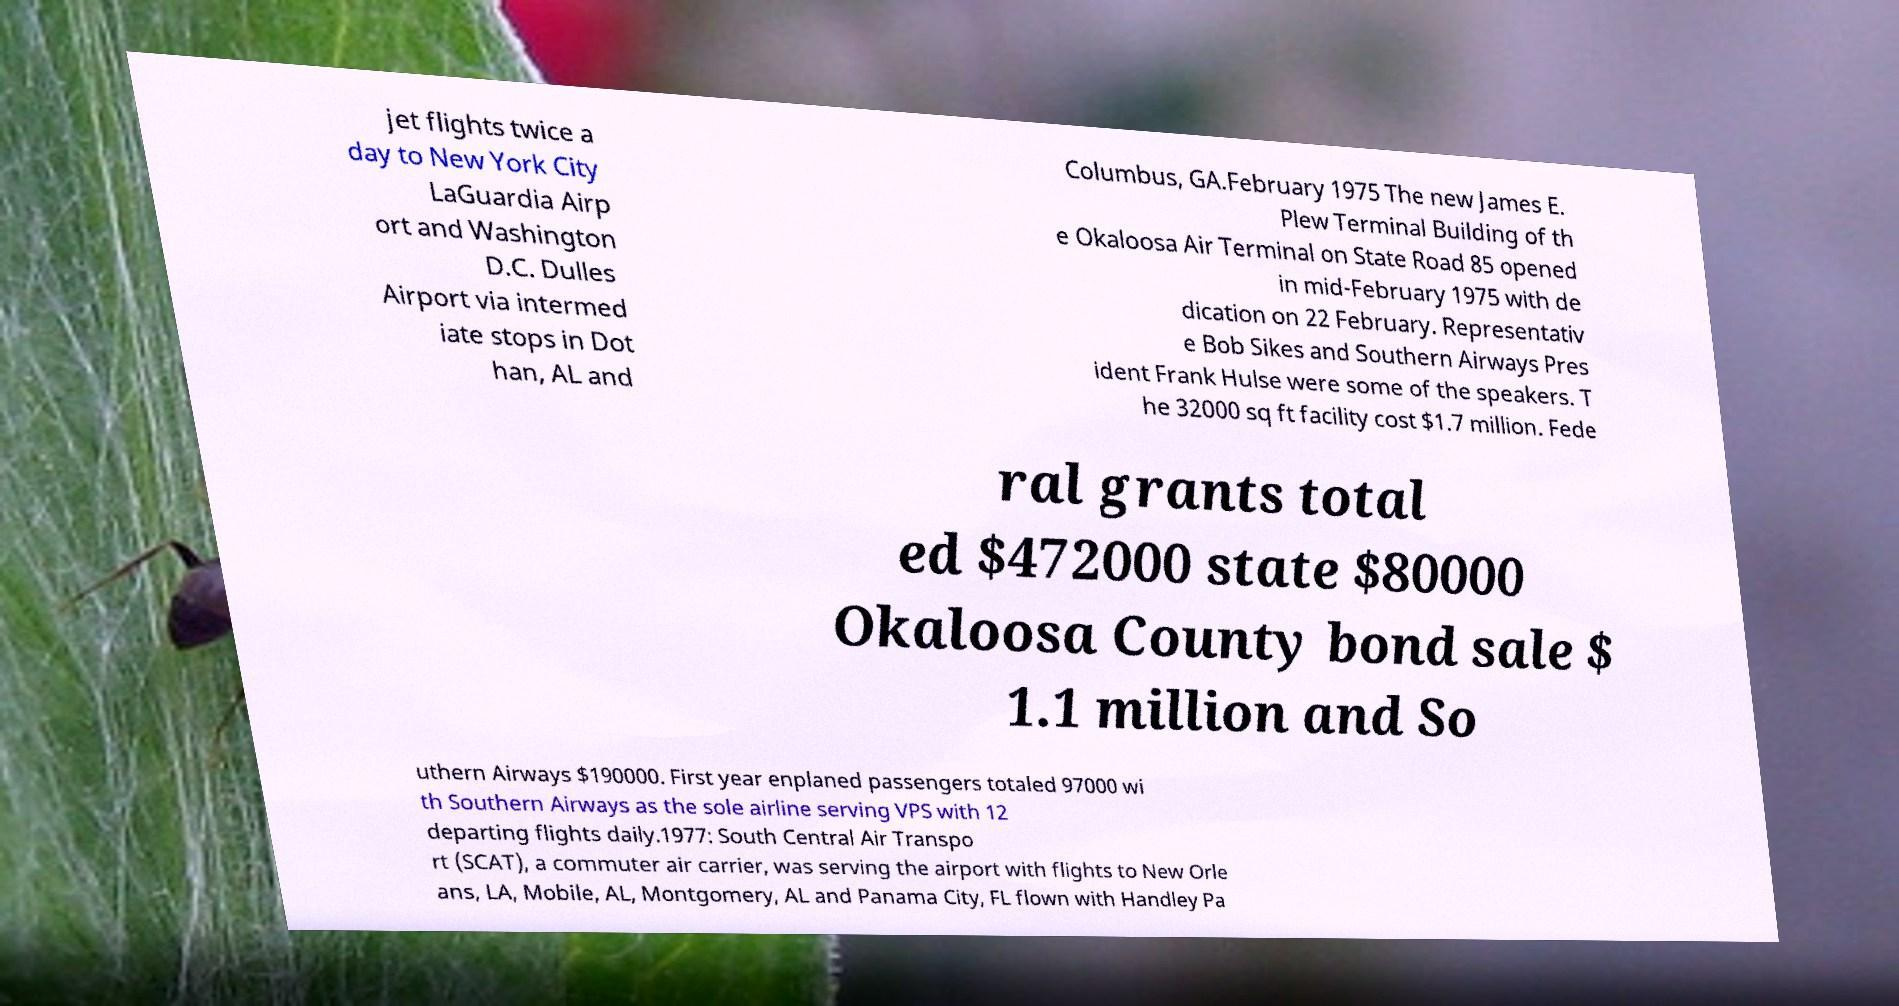Can you accurately transcribe the text from the provided image for me? jet flights twice a day to New York City LaGuardia Airp ort and Washington D.C. Dulles Airport via intermed iate stops in Dot han, AL and Columbus, GA.February 1975 The new James E. Plew Terminal Building of th e Okaloosa Air Terminal on State Road 85 opened in mid-February 1975 with de dication on 22 February. Representativ e Bob Sikes and Southern Airways Pres ident Frank Hulse were some of the speakers. T he 32000 sq ft facility cost $1.7 million. Fede ral grants total ed $472000 state $80000 Okaloosa County bond sale $ 1.1 million and So uthern Airways $190000. First year enplaned passengers totaled 97000 wi th Southern Airways as the sole airline serving VPS with 12 departing flights daily.1977: South Central Air Transpo rt (SCAT), a commuter air carrier, was serving the airport with flights to New Orle ans, LA, Mobile, AL, Montgomery, AL and Panama City, FL flown with Handley Pa 